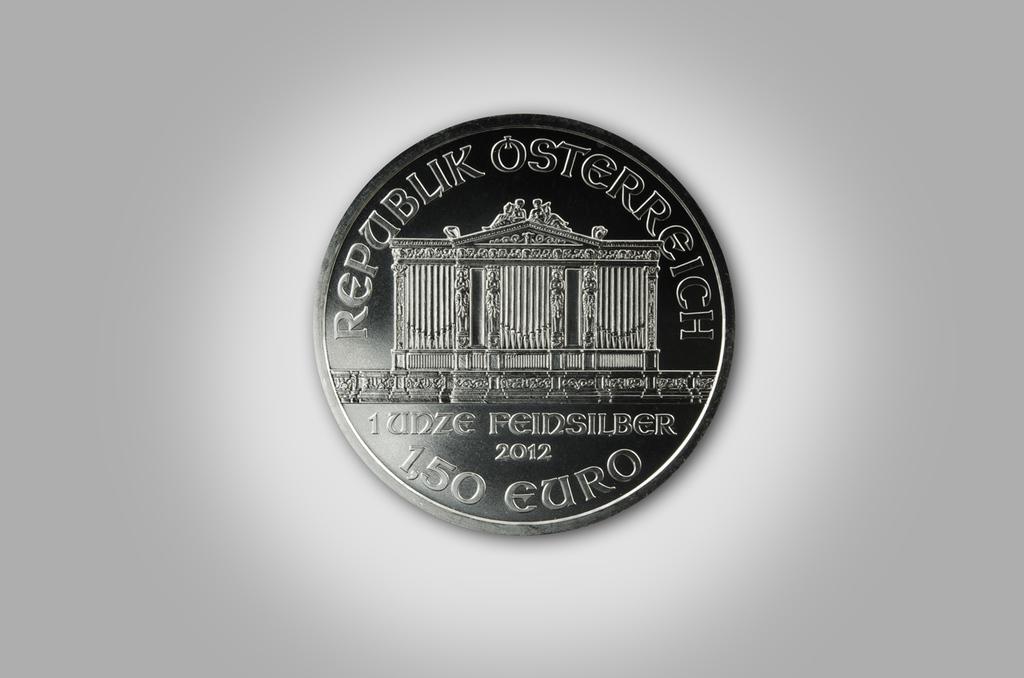What year was this coin printed?
Give a very brief answer. 2012. How many eruo's is this coin worth?
Offer a very short reply. 150. 